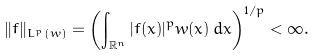<formula> <loc_0><loc_0><loc_500><loc_500>\| f \| _ { L ^ { p } ( w ) } = \left ( \int _ { \mathbb { R } ^ { n } } | f ( x ) | ^ { p } w ( x ) \, d x \right ) ^ { 1 / p } < \infty .</formula> 